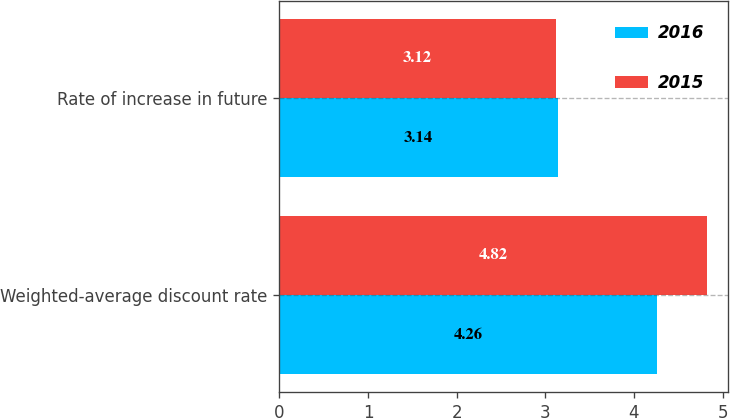Convert chart to OTSL. <chart><loc_0><loc_0><loc_500><loc_500><stacked_bar_chart><ecel><fcel>Weighted-average discount rate<fcel>Rate of increase in future<nl><fcel>2016<fcel>4.26<fcel>3.14<nl><fcel>2015<fcel>4.82<fcel>3.12<nl></chart> 